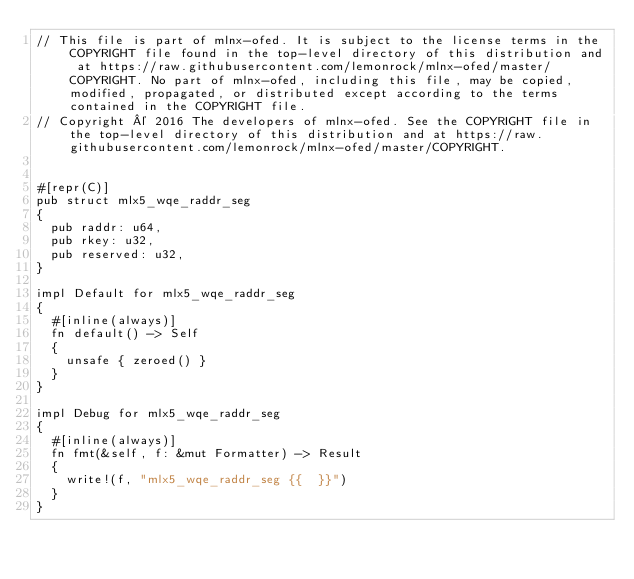<code> <loc_0><loc_0><loc_500><loc_500><_Rust_>// This file is part of mlnx-ofed. It is subject to the license terms in the COPYRIGHT file found in the top-level directory of this distribution and at https://raw.githubusercontent.com/lemonrock/mlnx-ofed/master/COPYRIGHT. No part of mlnx-ofed, including this file, may be copied, modified, propagated, or distributed except according to the terms contained in the COPYRIGHT file.
// Copyright © 2016 The developers of mlnx-ofed. See the COPYRIGHT file in the top-level directory of this distribution and at https://raw.githubusercontent.com/lemonrock/mlnx-ofed/master/COPYRIGHT.


#[repr(C)]
pub struct mlx5_wqe_raddr_seg
{
	pub raddr: u64,
	pub rkey: u32,
	pub reserved: u32,
}

impl Default for mlx5_wqe_raddr_seg
{
	#[inline(always)]
	fn default() -> Self
	{
		unsafe { zeroed() }
	}
}

impl Debug for mlx5_wqe_raddr_seg
{
	#[inline(always)]
	fn fmt(&self, f: &mut Formatter) -> Result
	{
		write!(f, "mlx5_wqe_raddr_seg {{  }}")
	}
}
</code> 